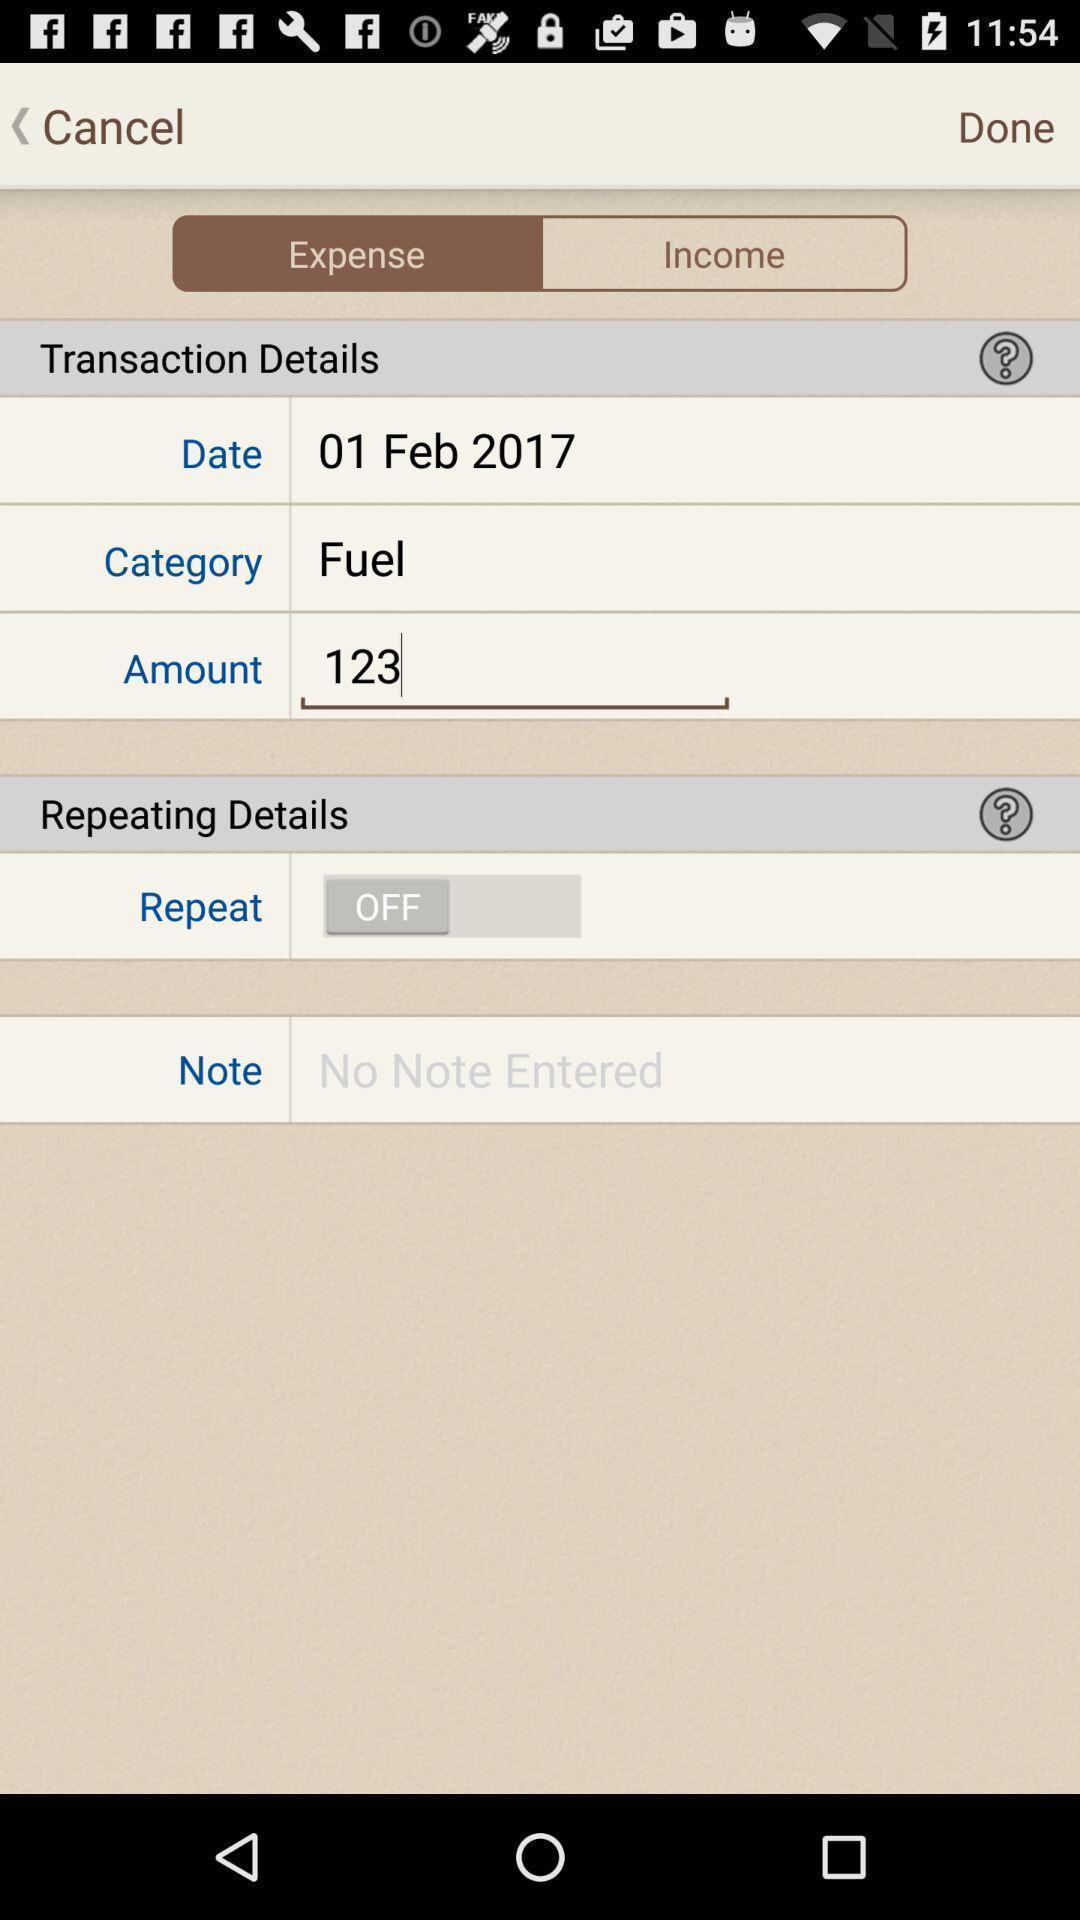Summarize the information in this screenshot. Transaction details in the financial application. 